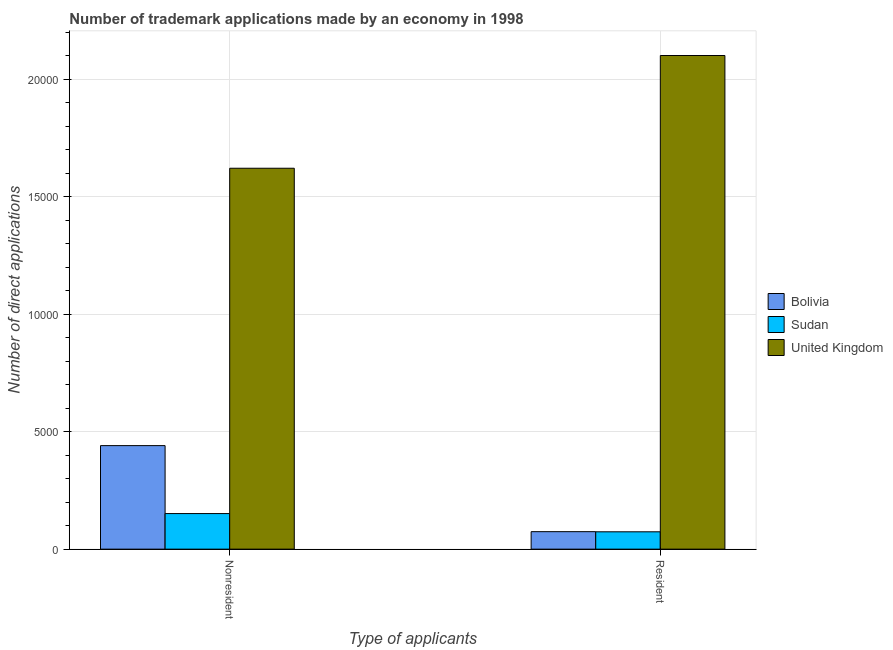How many different coloured bars are there?
Provide a short and direct response. 3. How many groups of bars are there?
Provide a short and direct response. 2. Are the number of bars per tick equal to the number of legend labels?
Offer a terse response. Yes. What is the label of the 2nd group of bars from the left?
Make the answer very short. Resident. What is the number of trademark applications made by residents in Sudan?
Provide a short and direct response. 738. Across all countries, what is the maximum number of trademark applications made by non residents?
Your answer should be compact. 1.62e+04. Across all countries, what is the minimum number of trademark applications made by non residents?
Offer a terse response. 1514. In which country was the number of trademark applications made by residents minimum?
Your answer should be compact. Sudan. What is the total number of trademark applications made by residents in the graph?
Provide a succinct answer. 2.25e+04. What is the difference between the number of trademark applications made by residents in Bolivia and that in United Kingdom?
Make the answer very short. -2.03e+04. What is the difference between the number of trademark applications made by residents in Sudan and the number of trademark applications made by non residents in Bolivia?
Your answer should be compact. -3667. What is the average number of trademark applications made by non residents per country?
Make the answer very short. 7375.33. What is the difference between the number of trademark applications made by non residents and number of trademark applications made by residents in Sudan?
Give a very brief answer. 776. In how many countries, is the number of trademark applications made by residents greater than 20000 ?
Ensure brevity in your answer.  1. What is the ratio of the number of trademark applications made by non residents in Bolivia to that in United Kingdom?
Make the answer very short. 0.27. Is the number of trademark applications made by residents in Bolivia less than that in Sudan?
Keep it short and to the point. No. In how many countries, is the number of trademark applications made by non residents greater than the average number of trademark applications made by non residents taken over all countries?
Ensure brevity in your answer.  1. What does the 3rd bar from the left in Resident represents?
Your answer should be very brief. United Kingdom. What does the 1st bar from the right in Nonresident represents?
Provide a succinct answer. United Kingdom. How many bars are there?
Make the answer very short. 6. Are all the bars in the graph horizontal?
Make the answer very short. No. Are the values on the major ticks of Y-axis written in scientific E-notation?
Keep it short and to the point. No. Does the graph contain any zero values?
Give a very brief answer. No. Does the graph contain grids?
Your answer should be very brief. Yes. What is the title of the graph?
Provide a short and direct response. Number of trademark applications made by an economy in 1998. What is the label or title of the X-axis?
Keep it short and to the point. Type of applicants. What is the label or title of the Y-axis?
Offer a very short reply. Number of direct applications. What is the Number of direct applications of Bolivia in Nonresident?
Your answer should be very brief. 4405. What is the Number of direct applications of Sudan in Nonresident?
Keep it short and to the point. 1514. What is the Number of direct applications in United Kingdom in Nonresident?
Make the answer very short. 1.62e+04. What is the Number of direct applications in Bolivia in Resident?
Provide a succinct answer. 744. What is the Number of direct applications of Sudan in Resident?
Make the answer very short. 738. What is the Number of direct applications of United Kingdom in Resident?
Offer a terse response. 2.10e+04. Across all Type of applicants, what is the maximum Number of direct applications in Bolivia?
Ensure brevity in your answer.  4405. Across all Type of applicants, what is the maximum Number of direct applications in Sudan?
Offer a terse response. 1514. Across all Type of applicants, what is the maximum Number of direct applications of United Kingdom?
Your response must be concise. 2.10e+04. Across all Type of applicants, what is the minimum Number of direct applications of Bolivia?
Your answer should be compact. 744. Across all Type of applicants, what is the minimum Number of direct applications in Sudan?
Make the answer very short. 738. Across all Type of applicants, what is the minimum Number of direct applications in United Kingdom?
Your answer should be very brief. 1.62e+04. What is the total Number of direct applications in Bolivia in the graph?
Keep it short and to the point. 5149. What is the total Number of direct applications in Sudan in the graph?
Give a very brief answer. 2252. What is the total Number of direct applications of United Kingdom in the graph?
Make the answer very short. 3.72e+04. What is the difference between the Number of direct applications of Bolivia in Nonresident and that in Resident?
Your answer should be compact. 3661. What is the difference between the Number of direct applications in Sudan in Nonresident and that in Resident?
Your response must be concise. 776. What is the difference between the Number of direct applications of United Kingdom in Nonresident and that in Resident?
Ensure brevity in your answer.  -4797. What is the difference between the Number of direct applications in Bolivia in Nonresident and the Number of direct applications in Sudan in Resident?
Give a very brief answer. 3667. What is the difference between the Number of direct applications in Bolivia in Nonresident and the Number of direct applications in United Kingdom in Resident?
Your answer should be very brief. -1.66e+04. What is the difference between the Number of direct applications in Sudan in Nonresident and the Number of direct applications in United Kingdom in Resident?
Your answer should be compact. -1.95e+04. What is the average Number of direct applications of Bolivia per Type of applicants?
Provide a succinct answer. 2574.5. What is the average Number of direct applications in Sudan per Type of applicants?
Give a very brief answer. 1126. What is the average Number of direct applications in United Kingdom per Type of applicants?
Keep it short and to the point. 1.86e+04. What is the difference between the Number of direct applications of Bolivia and Number of direct applications of Sudan in Nonresident?
Ensure brevity in your answer.  2891. What is the difference between the Number of direct applications of Bolivia and Number of direct applications of United Kingdom in Nonresident?
Provide a short and direct response. -1.18e+04. What is the difference between the Number of direct applications of Sudan and Number of direct applications of United Kingdom in Nonresident?
Make the answer very short. -1.47e+04. What is the difference between the Number of direct applications in Bolivia and Number of direct applications in Sudan in Resident?
Your response must be concise. 6. What is the difference between the Number of direct applications of Bolivia and Number of direct applications of United Kingdom in Resident?
Provide a short and direct response. -2.03e+04. What is the difference between the Number of direct applications in Sudan and Number of direct applications in United Kingdom in Resident?
Keep it short and to the point. -2.03e+04. What is the ratio of the Number of direct applications of Bolivia in Nonresident to that in Resident?
Give a very brief answer. 5.92. What is the ratio of the Number of direct applications of Sudan in Nonresident to that in Resident?
Give a very brief answer. 2.05. What is the ratio of the Number of direct applications in United Kingdom in Nonresident to that in Resident?
Your answer should be very brief. 0.77. What is the difference between the highest and the second highest Number of direct applications of Bolivia?
Your answer should be very brief. 3661. What is the difference between the highest and the second highest Number of direct applications of Sudan?
Offer a terse response. 776. What is the difference between the highest and the second highest Number of direct applications of United Kingdom?
Offer a very short reply. 4797. What is the difference between the highest and the lowest Number of direct applications of Bolivia?
Ensure brevity in your answer.  3661. What is the difference between the highest and the lowest Number of direct applications in Sudan?
Provide a succinct answer. 776. What is the difference between the highest and the lowest Number of direct applications in United Kingdom?
Give a very brief answer. 4797. 